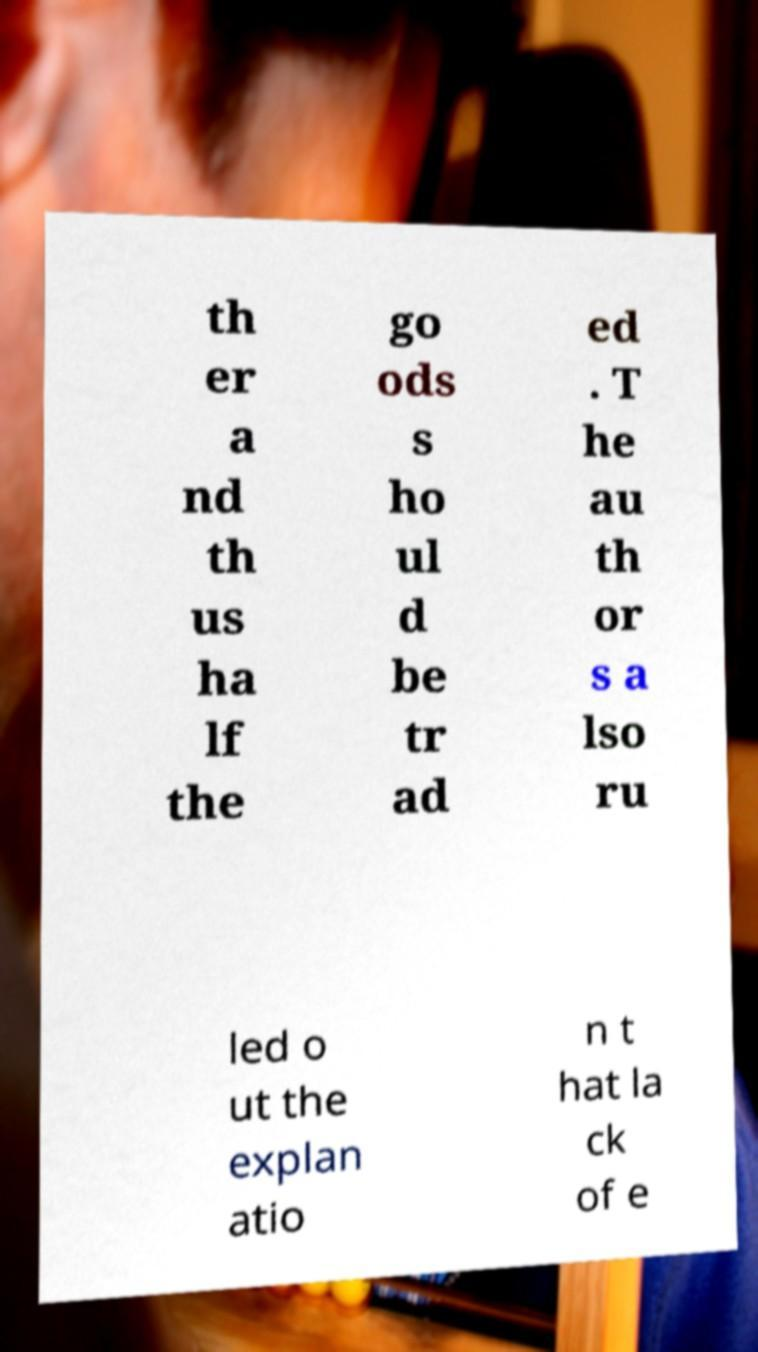Please read and relay the text visible in this image. What does it say? th er a nd th us ha lf the go ods s ho ul d be tr ad ed . T he au th or s a lso ru led o ut the explan atio n t hat la ck of e 